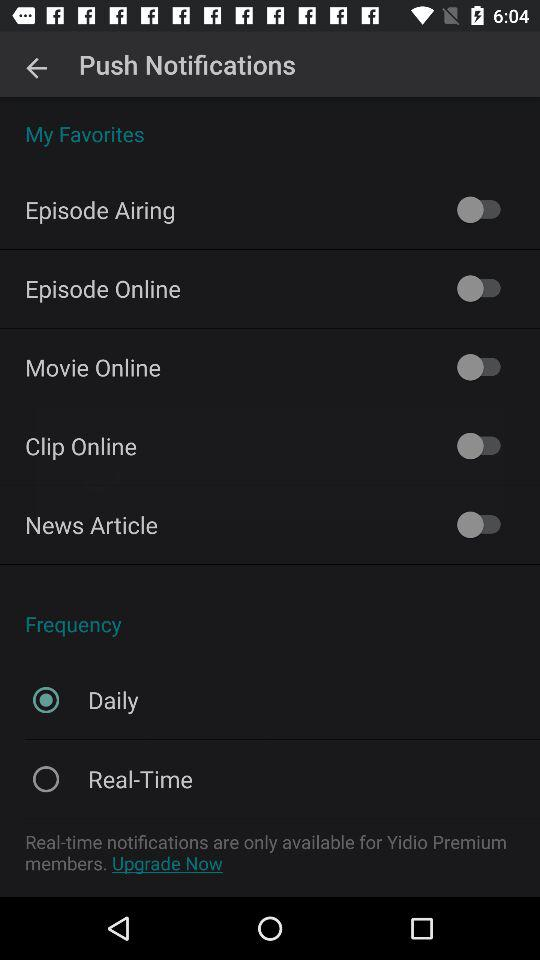What is the status of the "Movie Online"? The status is "off". 